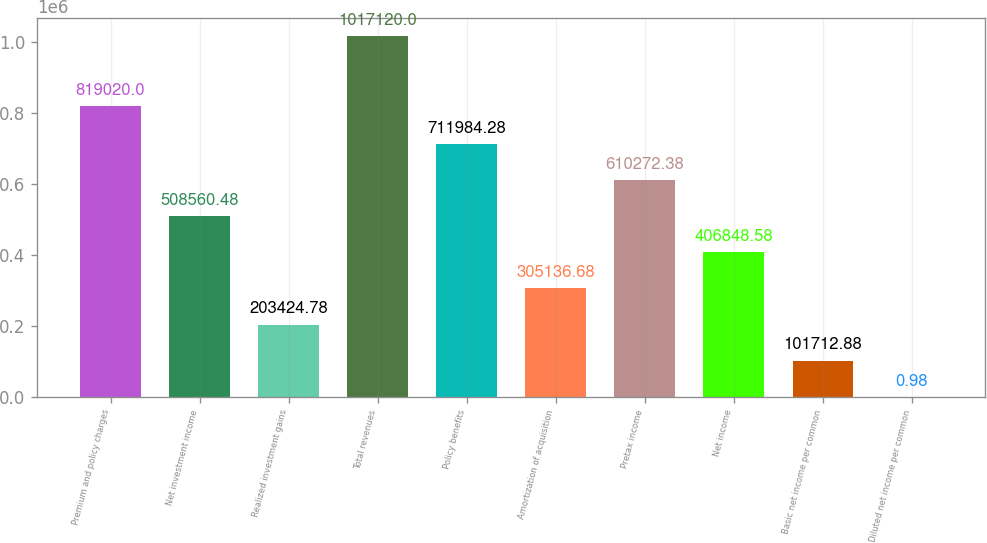Convert chart to OTSL. <chart><loc_0><loc_0><loc_500><loc_500><bar_chart><fcel>Premium and policy charges<fcel>Net investment income<fcel>Realized investment gains<fcel>Total revenues<fcel>Policy benefits<fcel>Amortization of acquisition<fcel>Pretax income<fcel>Net income<fcel>Basic net income per common<fcel>Diluted net income per common<nl><fcel>819020<fcel>508560<fcel>203425<fcel>1.01712e+06<fcel>711984<fcel>305137<fcel>610272<fcel>406849<fcel>101713<fcel>0.98<nl></chart> 